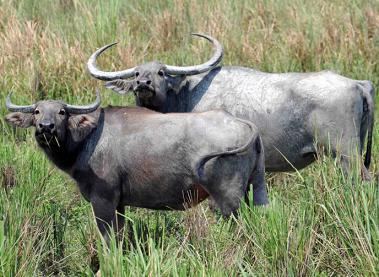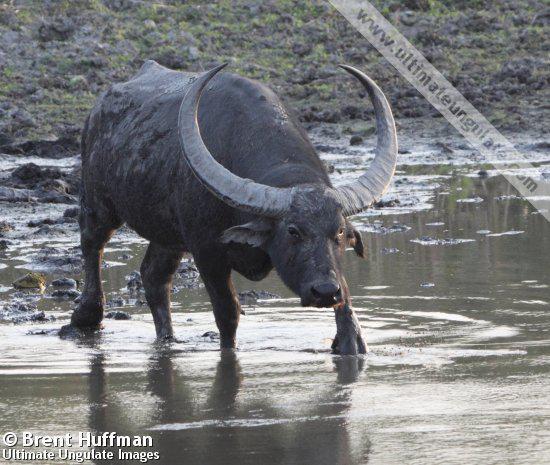The first image is the image on the left, the second image is the image on the right. Evaluate the accuracy of this statement regarding the images: "Two animals are standing in the grass in one of the pictures.". Is it true? Answer yes or no. Yes. The first image is the image on the left, the second image is the image on the right. For the images displayed, is the sentence "There are 3 animals in the images" factually correct? Answer yes or no. Yes. 